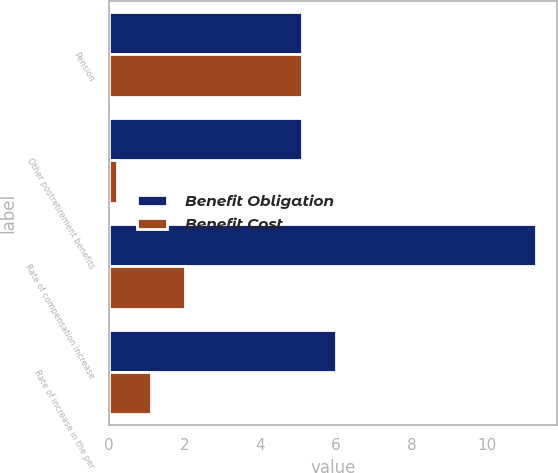<chart> <loc_0><loc_0><loc_500><loc_500><stacked_bar_chart><ecel><fcel>Pension<fcel>Other postretirement benefits<fcel>Rate of compensation increase<fcel>Rate of increase in the per<nl><fcel>Benefit Obligation<fcel>5.1<fcel>5.1<fcel>11.3<fcel>6<nl><fcel>Benefit Cost<fcel>5.1<fcel>0.2<fcel>2<fcel>1.1<nl></chart> 